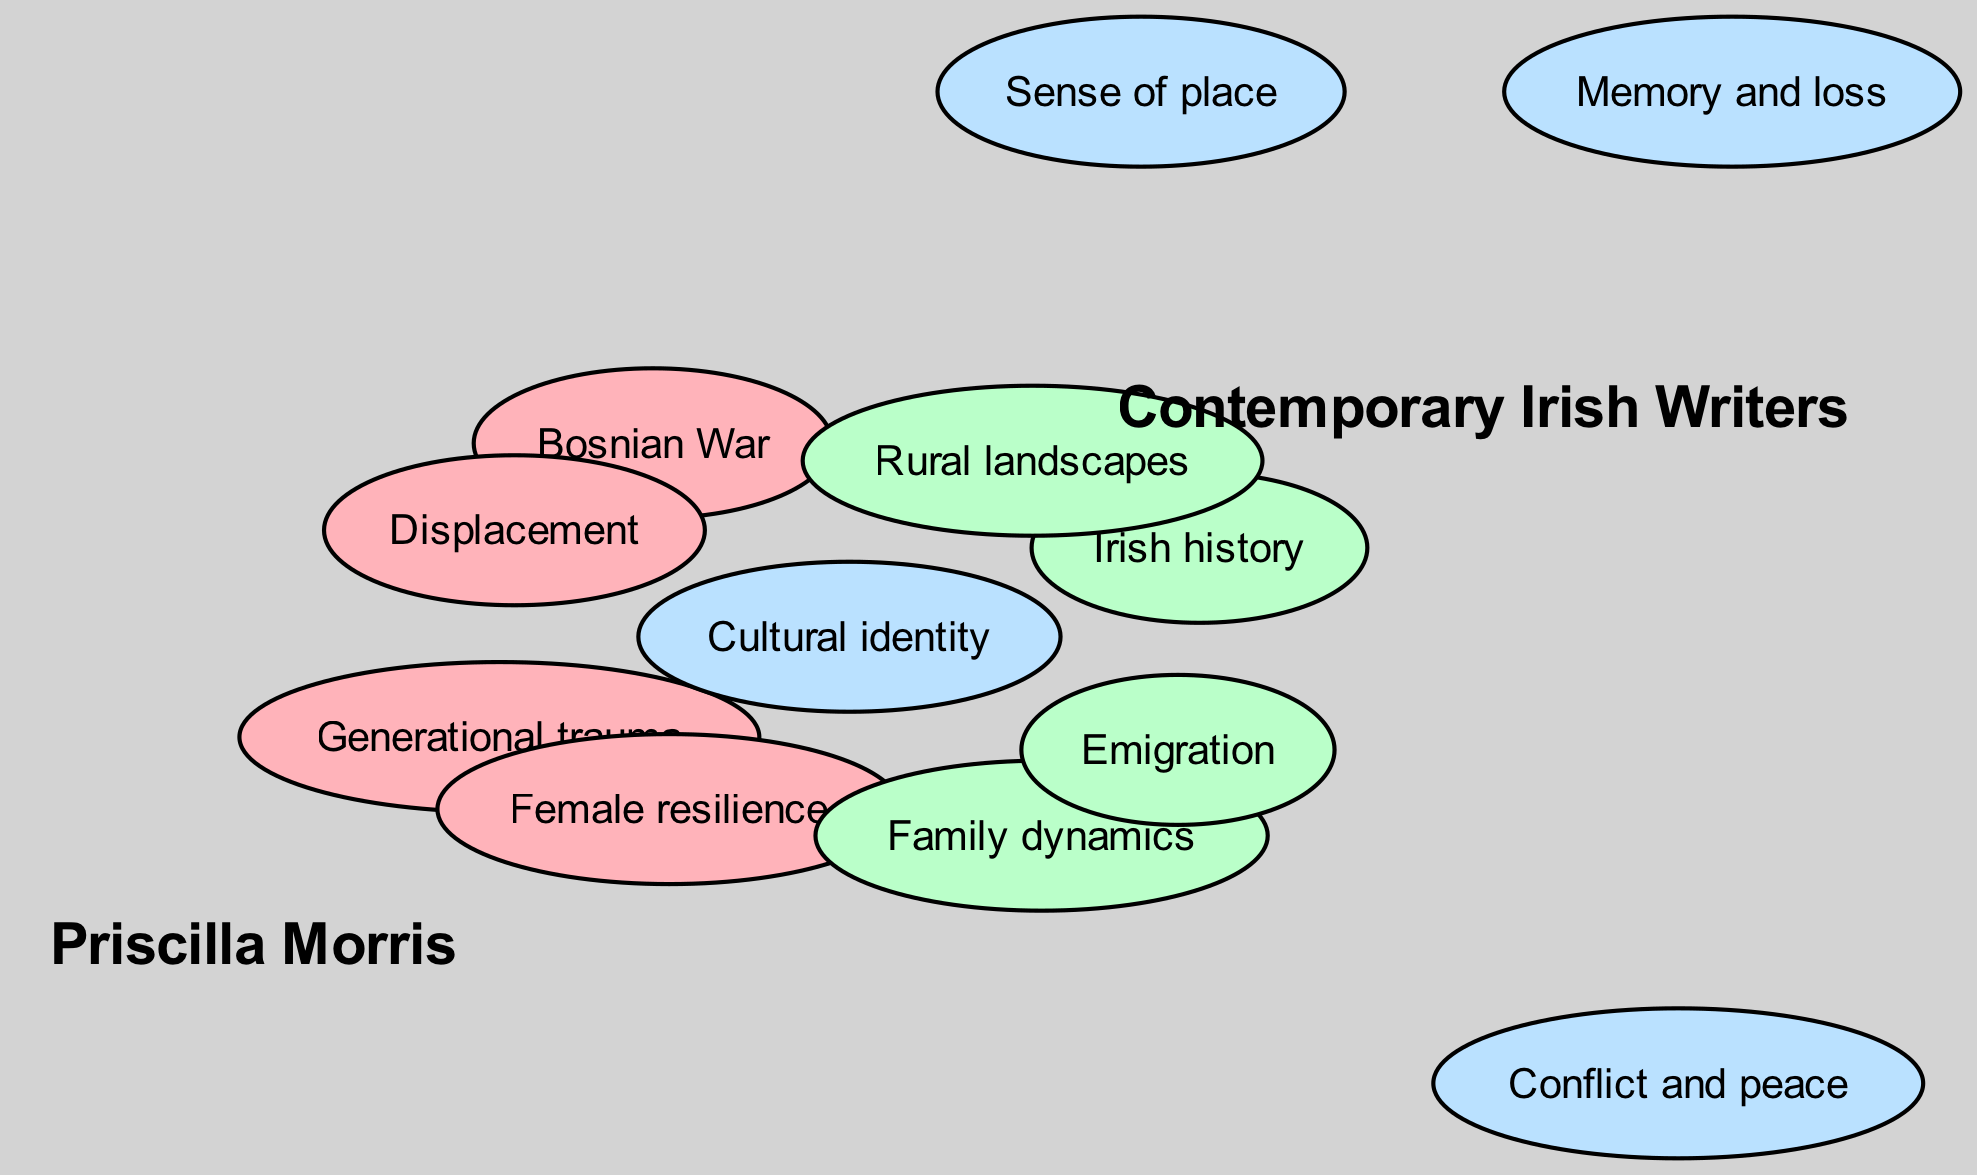What themes are unique to Priscilla Morris's works? The diagram lists five themes unique to Priscilla Morris's works, specifically: generational trauma, Bosnian War, female resilience, cultural identity, and displacement. By reviewing the nodes associated with Priscilla Morris, we can identify which themes are not shared with contemporary Irish writers.
Answer: generational trauma, Bosnian War, female resilience, displacement What themes are shared between Priscilla Morris and contemporary Irish writers? The diagram highlights four shared themes between the two authors: cultural identity, conflict and peace, memory and loss, and sense of place. We can see these themes grouped in the area of overlap in the diagram.
Answer: cultural identity, conflict and peace, memory and loss, sense of place How many unique themes does contemporary Irish writers have? There are four unique themes identified for contemporary Irish writers: Irish history, rural landscapes, family dynamics, and emigration. By counting the themes that are listed solely under contemporary Irish writers in the diagram, we can arrive at this number.
Answer: four Which theme relates to both Priscilla Morris and contemporary Irish writers regarding the idea of national impact? The theme "cultural identity" relates to both Priscilla Morris and contemporary Irish writers. This theme is evidenced in the overlap section of the diagram, indicating that it's a key concept for both authors.
Answer: cultural identity How many themes does Priscilla Morris have that do not overlap with contemporary Irish writers? Priscilla Morris has four themes that do not overlap with contemporary Irish writers. By examining the individual themes listed under Priscilla Morris, we can count those that are not found in the contemporary Irish writers' section of the diagram.
Answer: four Which element indicates the theme of nostalgia and memory in the diagram? The element "memory and loss" indicates the theme of nostalgia and memory, as it is specifically mentioned in the common themes area where both authors intersect. This reflects how both authors tackle similar emotional experiences.
Answer: memory and loss What common element addresses warfare and resolution in the diagram? The common element that addresses warfare and resolution is "conflict and peace." This theme is positioned in the overlap area, signifying that it resonates with both Priscilla Morris and contemporary Irish writers, focusing on societal and personal conflicts.
Answer: conflict and peace How many total themes are presented in the diagram? There are a total of nine themes presented in the diagram. This total is derived by counting the unique themes in both sets and the shared themes within the overlap area.
Answer: nine 